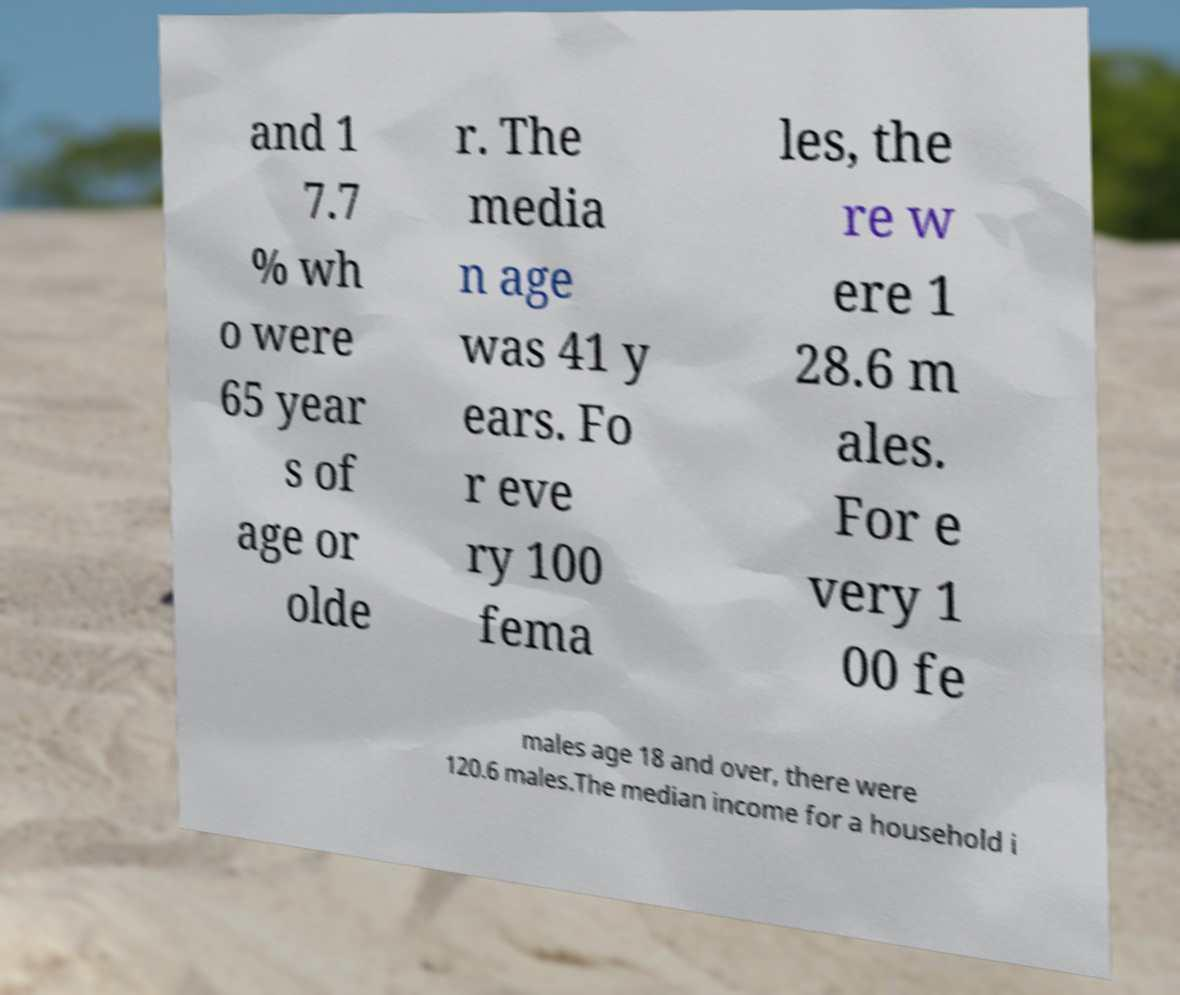Could you assist in decoding the text presented in this image and type it out clearly? and 1 7.7 % wh o were 65 year s of age or olde r. The media n age was 41 y ears. Fo r eve ry 100 fema les, the re w ere 1 28.6 m ales. For e very 1 00 fe males age 18 and over, there were 120.6 males.The median income for a household i 